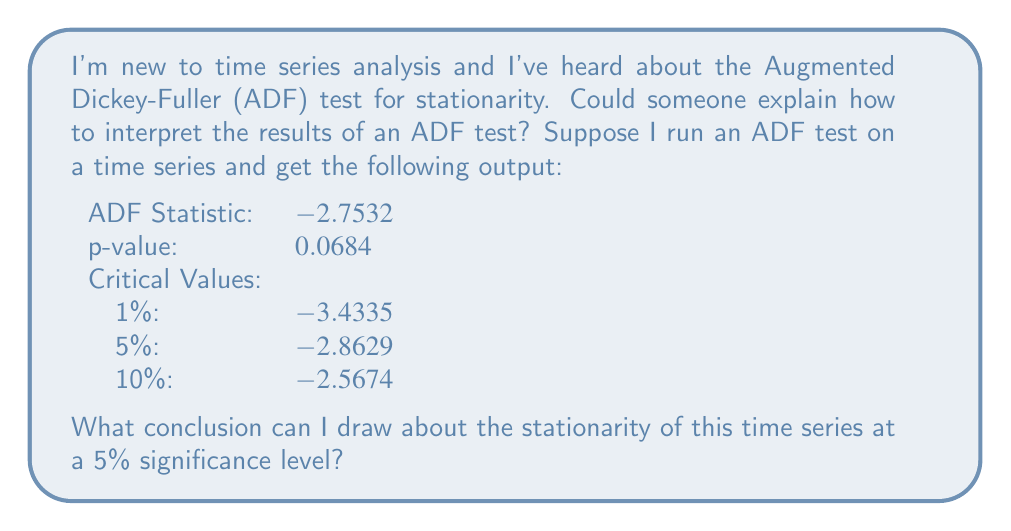Could you help me with this problem? To interpret the results of an Augmented Dickey-Fuller (ADF) test, we need to understand its null and alternative hypotheses:

Null hypothesis ($H_0$): The time series has a unit root (non-stationary)
Alternative hypothesis ($H_1$): The time series does not have a unit root (stationary)

To draw a conclusion, we need to compare two values:

1. The ADF test statistic
2. The critical value at the chosen significance level

In this case, we're using a 5% significance level, so we'll compare the ADF test statistic to the 5% critical value.

ADF test statistic: -2.7532
5% critical value: -2.8629

The decision rule is:
- If the ADF test statistic is less than (more negative than) the critical value, we reject the null hypothesis.
- If the ADF test statistic is greater than (less negative than) the critical value, we fail to reject the null hypothesis.

In this case:
$-2.7532 > -2.8629$

The ADF test statistic (-2.7532) is greater than (less negative than) the 5% critical value (-2.8629).

We can also confirm this using the p-value:
- If the p-value is less than the significance level (0.05), we reject the null hypothesis.
- If the p-value is greater than the significance level (0.05), we fail to reject the null hypothesis.

The p-value (0.0684) is greater than 0.05.

Both methods lead to the same conclusion: we fail to reject the null hypothesis at the 5% significance level.
Answer: At a 5% significance level, we fail to reject the null hypothesis. This means we do not have sufficient evidence to conclude that the time series is stationary. The data suggests that the time series may have a unit root and could be non-stationary. 